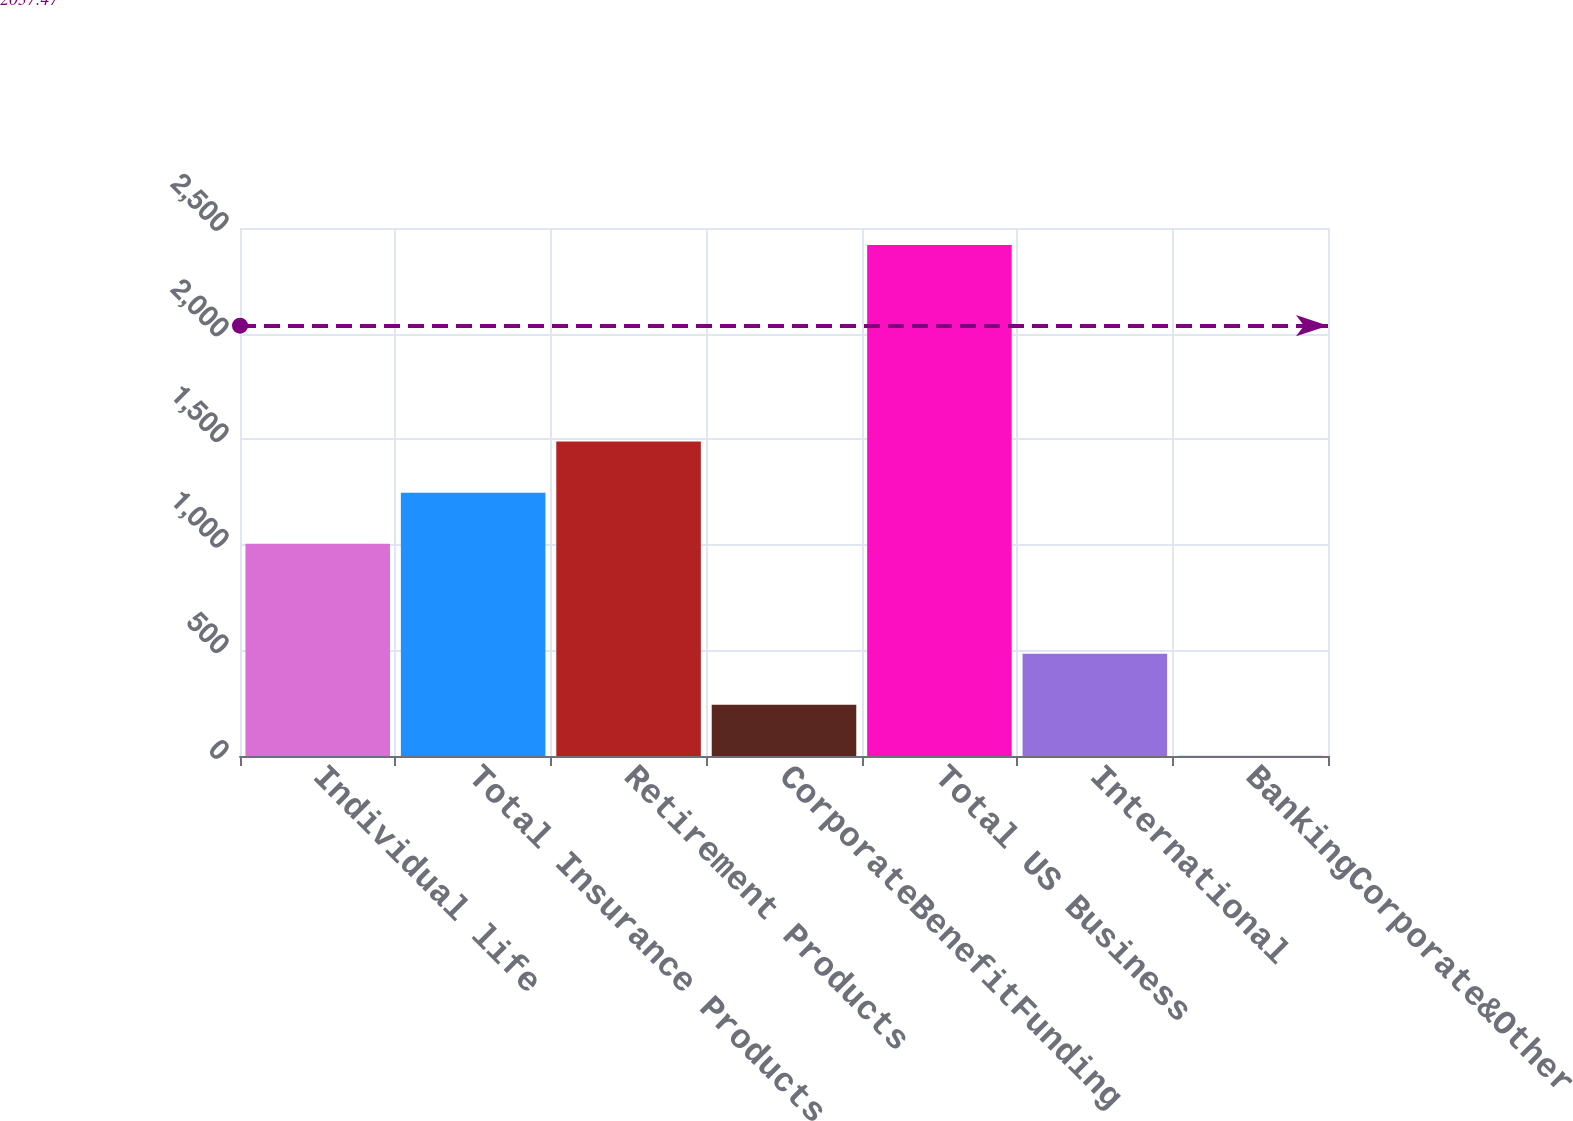<chart> <loc_0><loc_0><loc_500><loc_500><bar_chart><fcel>Individual life<fcel>Total Insurance Products<fcel>Retirement Products<fcel>CorporateBenefitFunding<fcel>Total US Business<fcel>International<fcel>BankingCorporate&Other<nl><fcel>1005<fcel>1246.8<fcel>1488.6<fcel>242.8<fcel>2419<fcel>484.6<fcel>1<nl></chart> 